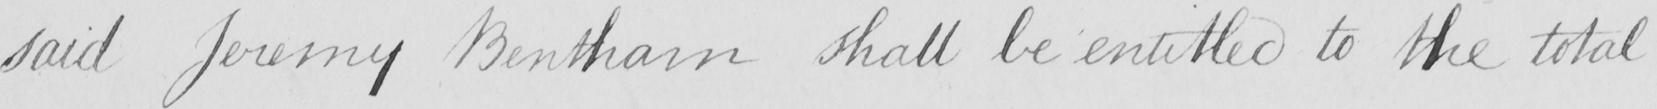What does this handwritten line say? said Jeremy Bentham shall be entitled to the total 